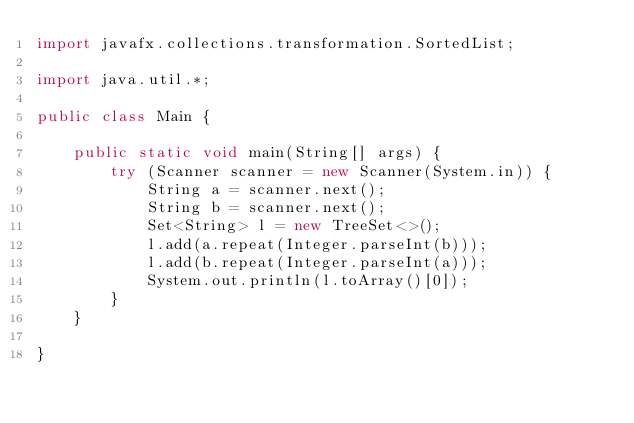<code> <loc_0><loc_0><loc_500><loc_500><_Java_>import javafx.collections.transformation.SortedList;

import java.util.*;

public class Main {

    public static void main(String[] args) {
        try (Scanner scanner = new Scanner(System.in)) {
            String a = scanner.next();
            String b = scanner.next();
            Set<String> l = new TreeSet<>();
            l.add(a.repeat(Integer.parseInt(b)));
            l.add(b.repeat(Integer.parseInt(a)));
            System.out.println(l.toArray()[0]);
        }
    }

}
</code> 